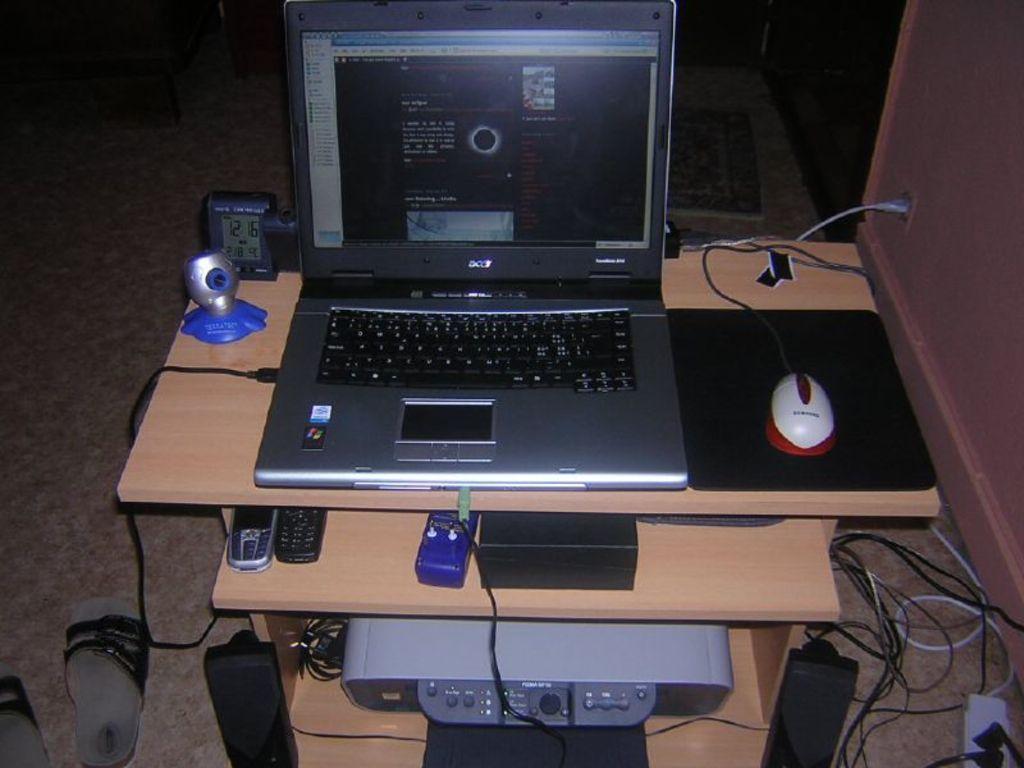Describe this image in one or two sentences. This is a computer table. On the table there is a laptop, mouse, touchpad, timer, webcam. And on the drawer there are mobiles. And there are wires, chapels,and speakers on the floor. 